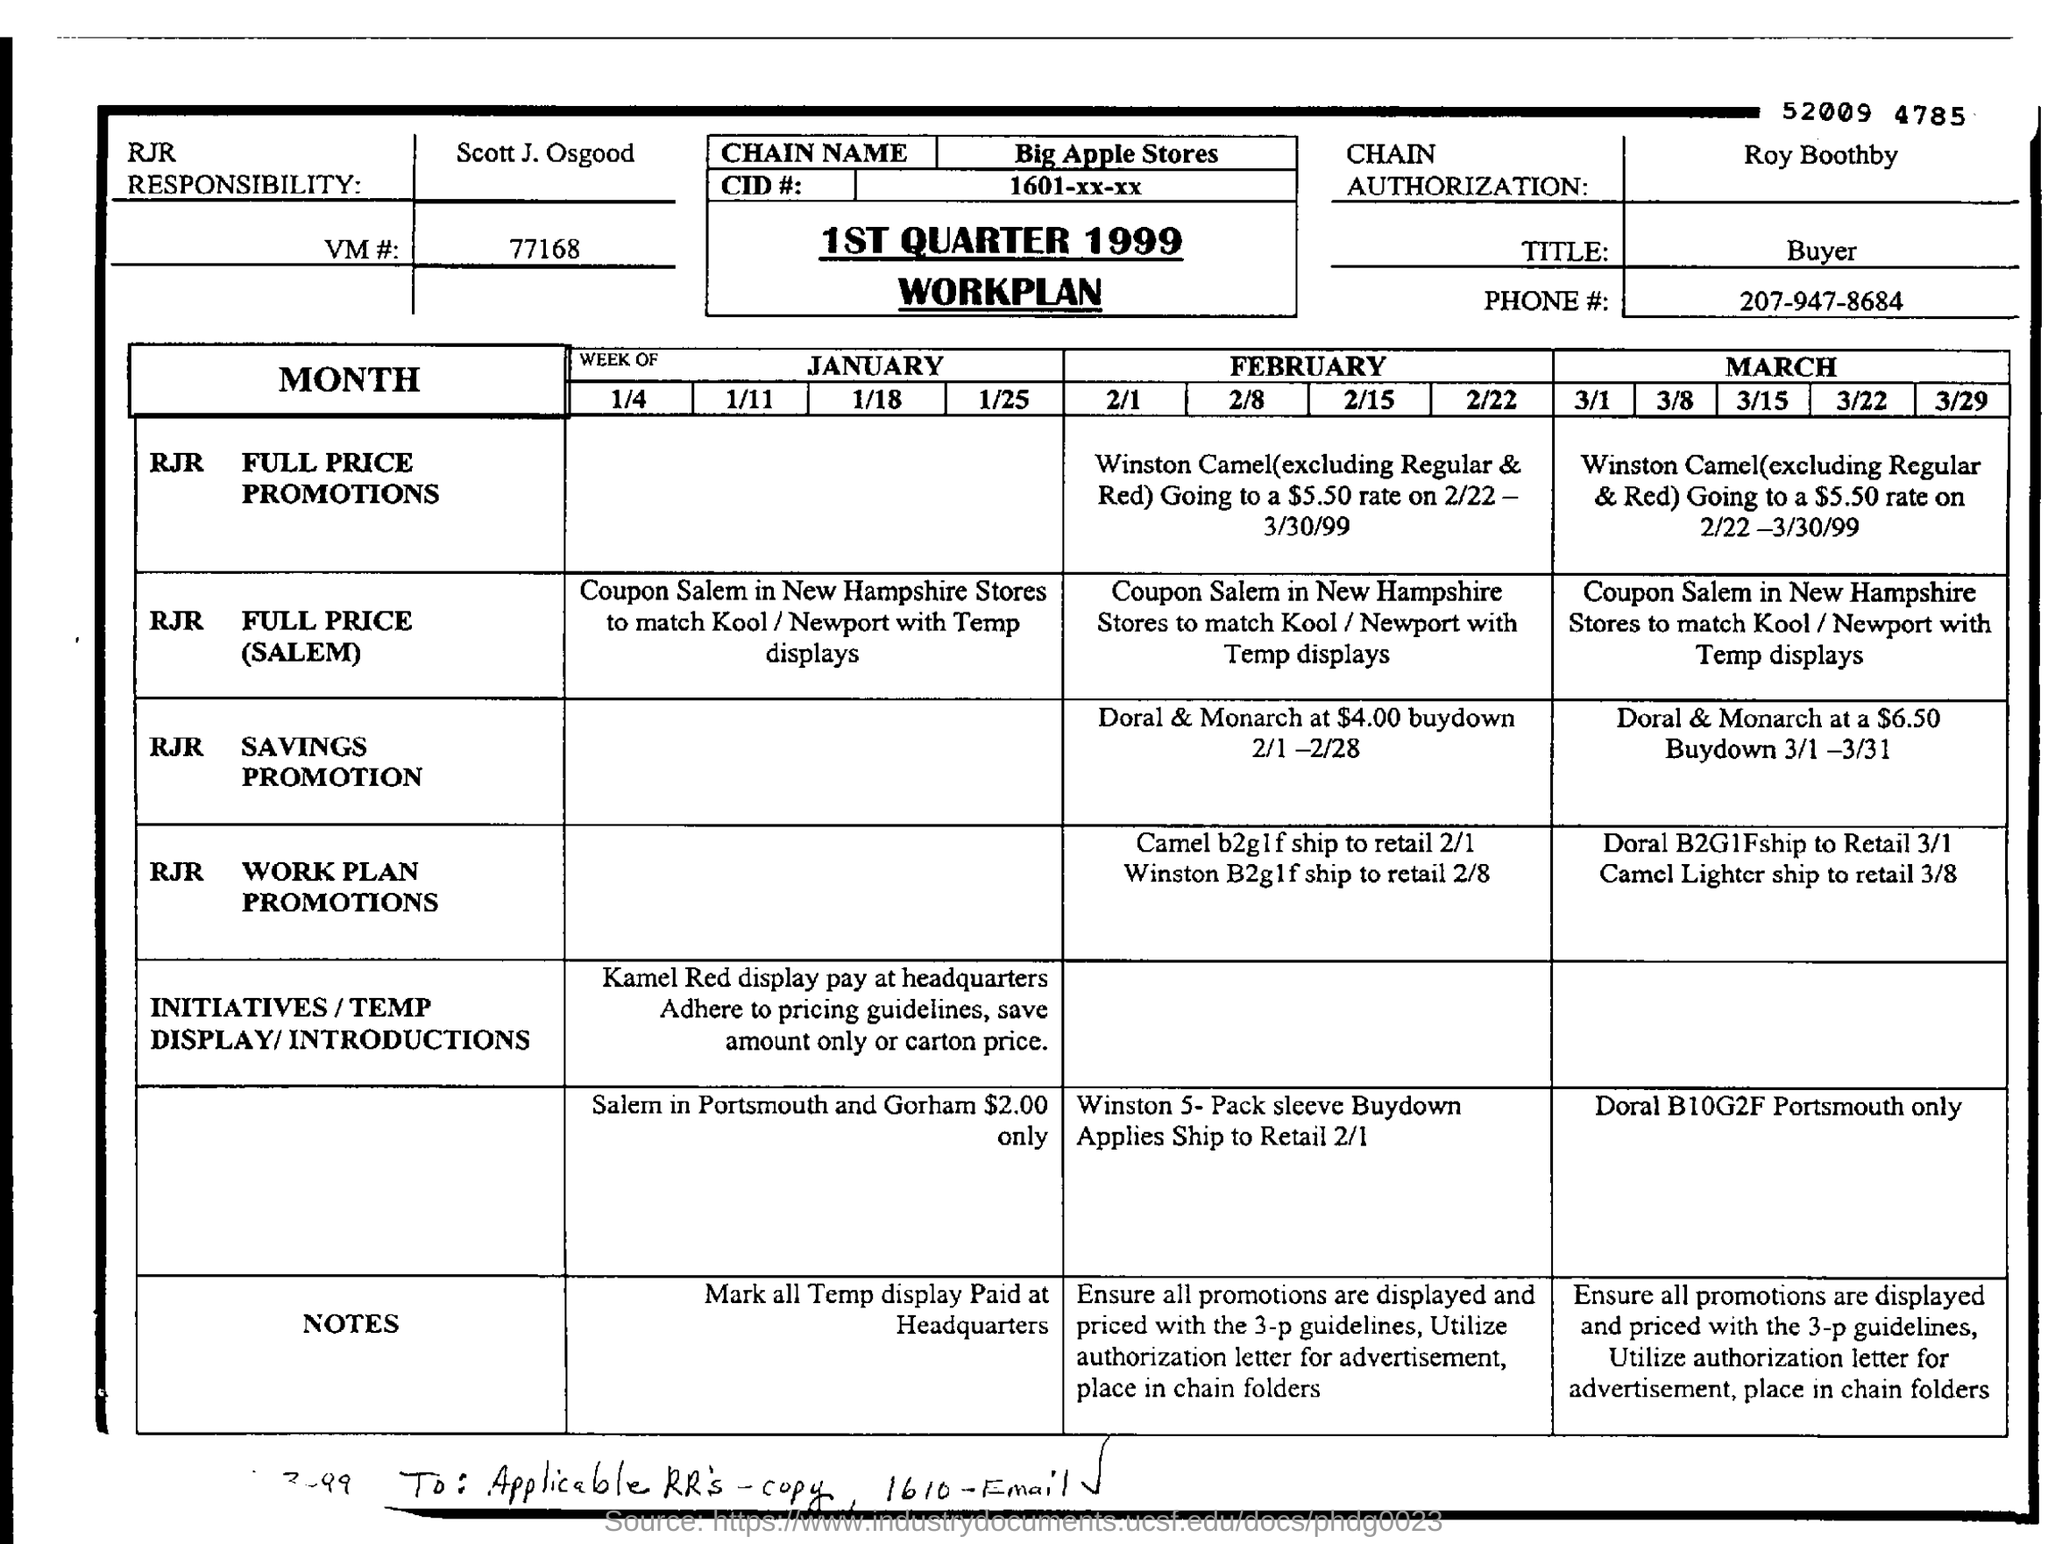What is the name of the workplan?
Make the answer very short. 1ST QUARTER 1999 WORKPLAN. Who is mentioned in the CHAIN AUTHORIZATION?
Make the answer very short. Roy Boothby. What is the title mentioned?
Your response must be concise. Buyer. What is the PHONE# mentioned?
Offer a terse response. 207-947-8684. 